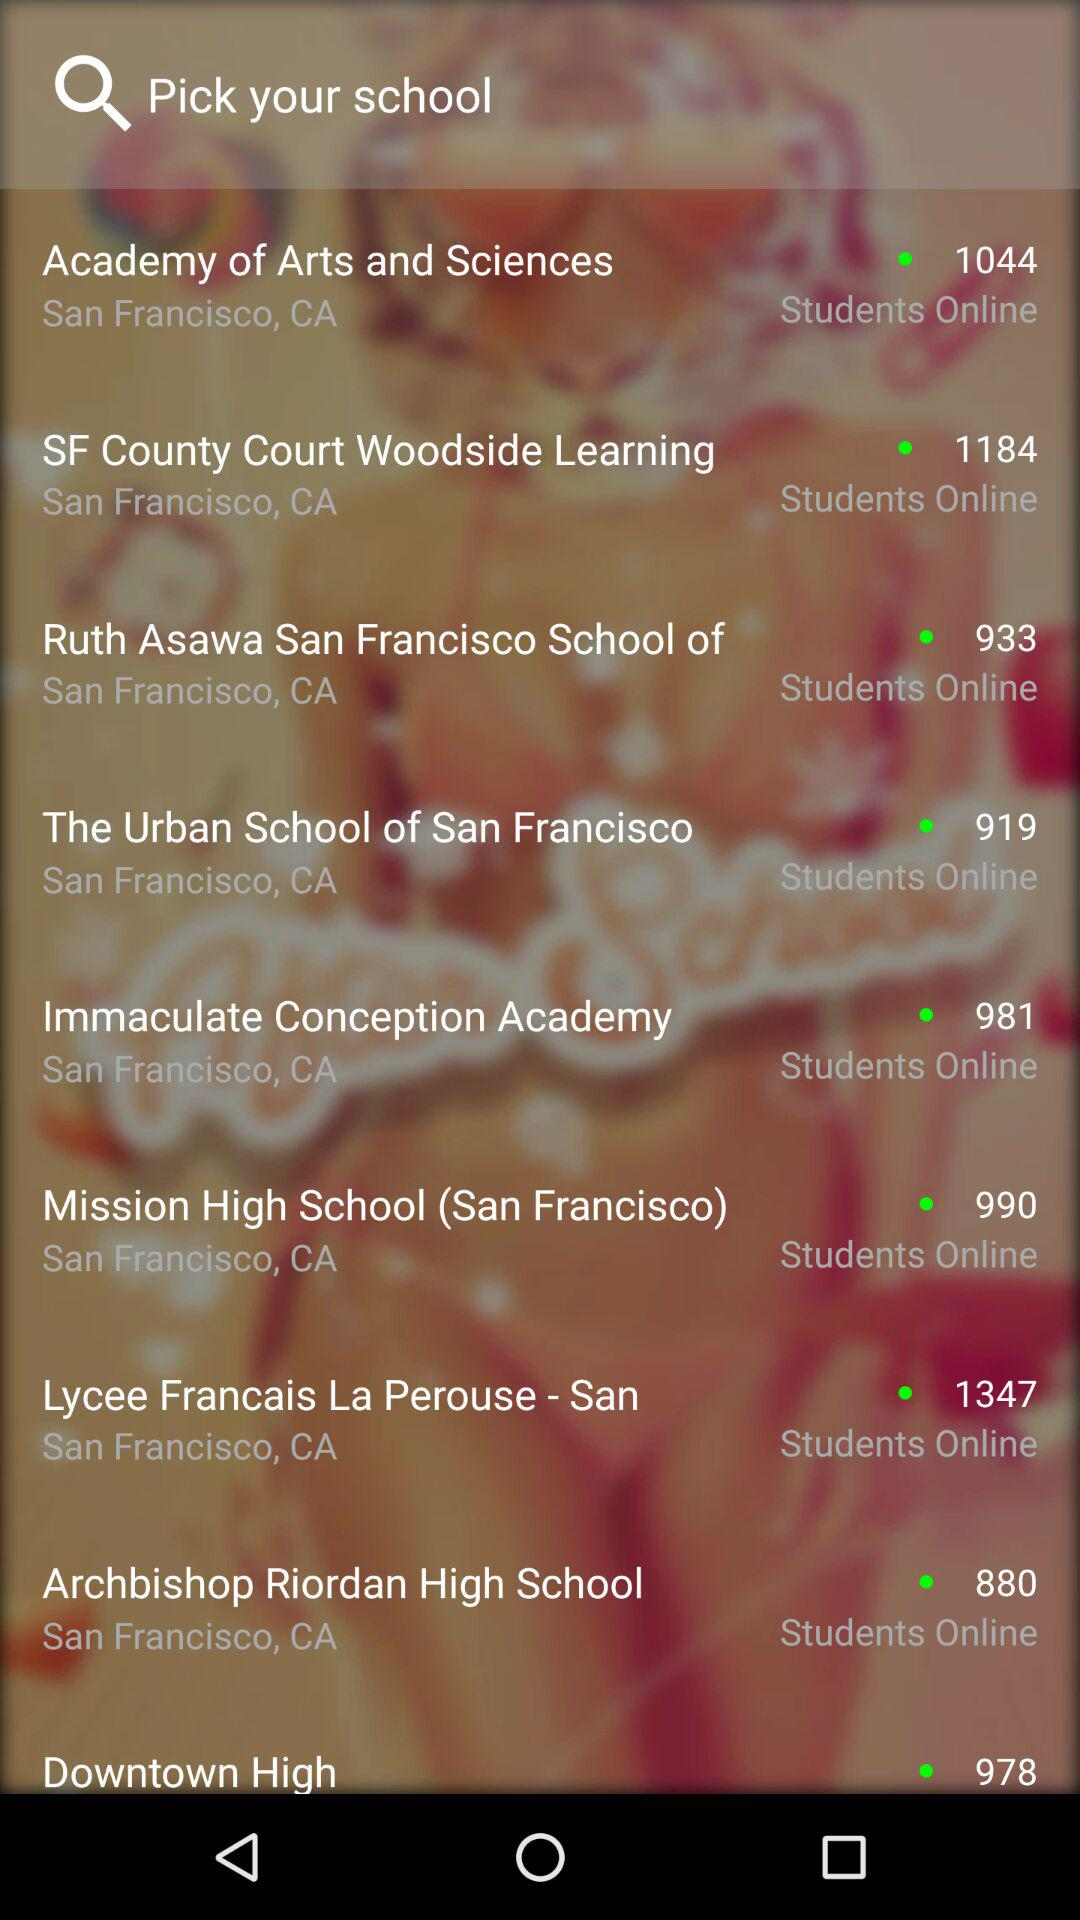How many students of "Mission High School" are online? The number of students who are online is 990. 